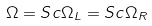Convert formula to latex. <formula><loc_0><loc_0><loc_500><loc_500>\Omega = S c \Omega _ { L } = S c \Omega _ { R }</formula> 